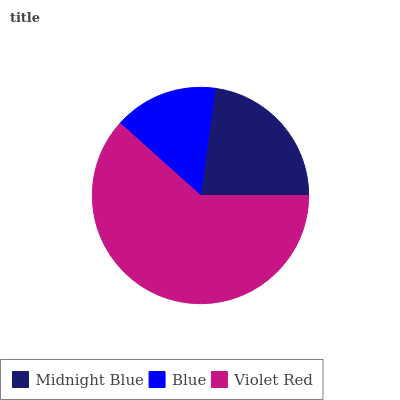Is Blue the minimum?
Answer yes or no. Yes. Is Violet Red the maximum?
Answer yes or no. Yes. Is Violet Red the minimum?
Answer yes or no. No. Is Blue the maximum?
Answer yes or no. No. Is Violet Red greater than Blue?
Answer yes or no. Yes. Is Blue less than Violet Red?
Answer yes or no. Yes. Is Blue greater than Violet Red?
Answer yes or no. No. Is Violet Red less than Blue?
Answer yes or no. No. Is Midnight Blue the high median?
Answer yes or no. Yes. Is Midnight Blue the low median?
Answer yes or no. Yes. Is Blue the high median?
Answer yes or no. No. Is Blue the low median?
Answer yes or no. No. 